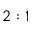Convert formula to latex. <formula><loc_0><loc_0><loc_500><loc_500>2 \colon 1</formula> 